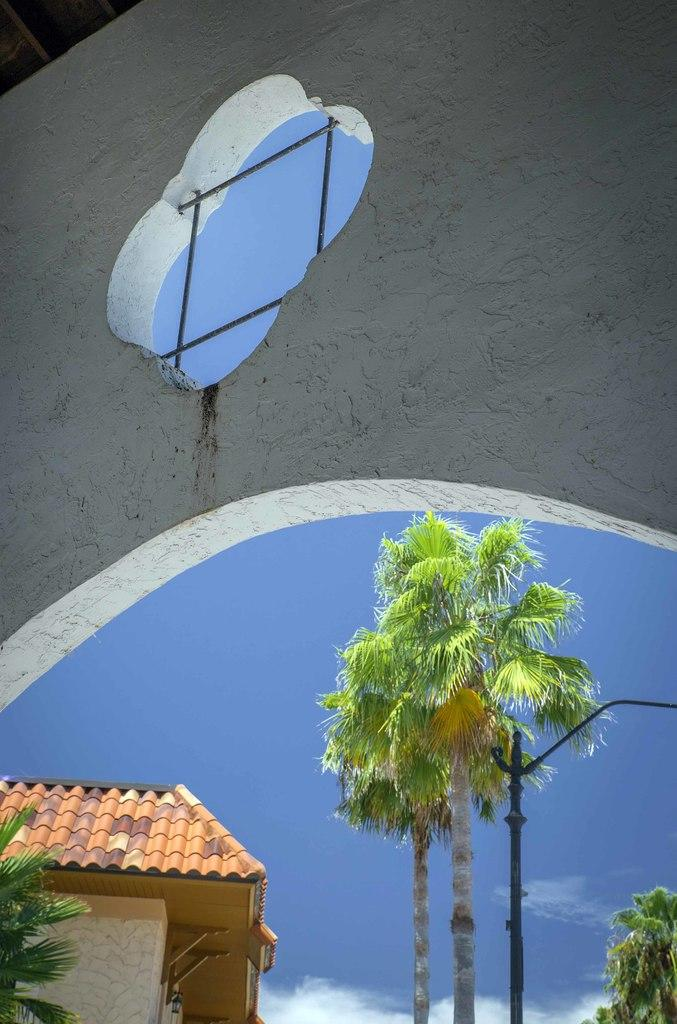What type of structure is located at the bottom of the image? There is a house at the bottom of the image. What other objects can be seen at the bottom of the image? There are trees and a pole at the bottom of the image. What is visible at the bottom of the image? The sky is visible at the bottom of the image. What type of structure is located at the top of the image? There is a wall at the top of the image. What object is associated with cooking at the top of the image? There is a grill at the top of the image. What type of machine is used for cleaning the sky in the image? There is no machine present in the image, and the sky does not require cleaning. Can you see a glove being used for gardening in the image? There is no glove present in the image, and no gardening activity is depicted. 